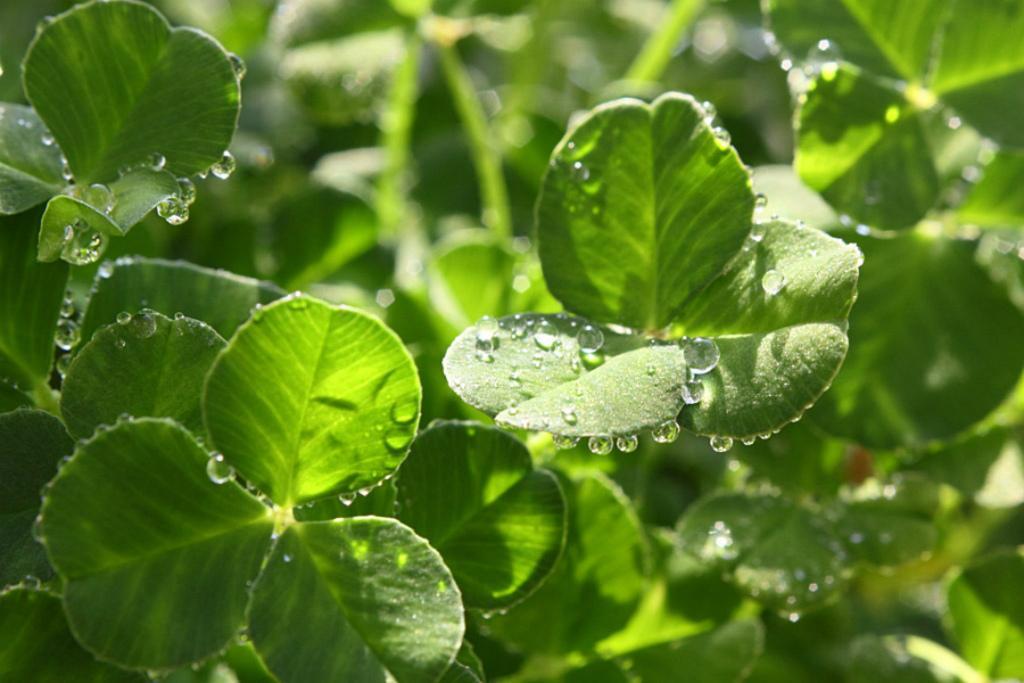In one or two sentences, can you explain what this image depicts? In this image we can see leaves with water droplets. In the background it is blur. 